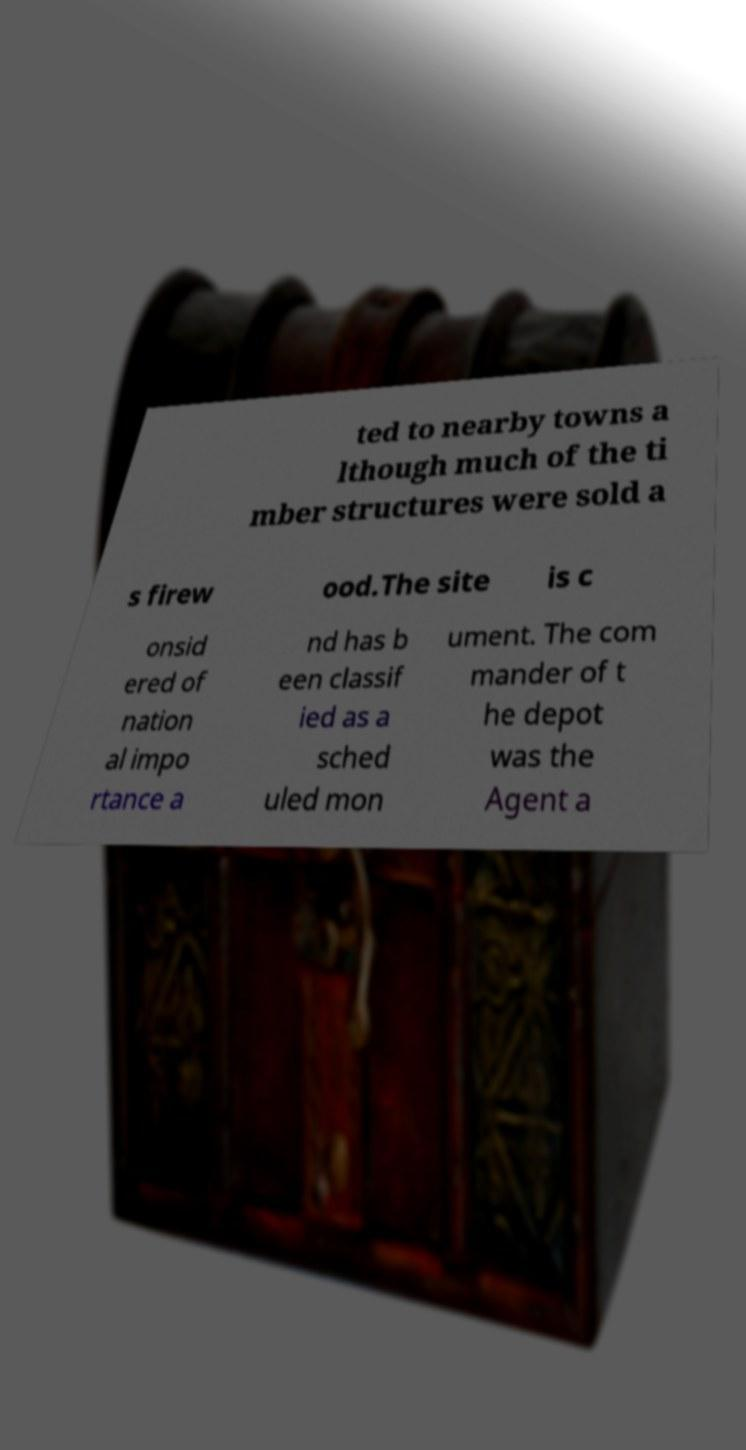Can you read and provide the text displayed in the image?This photo seems to have some interesting text. Can you extract and type it out for me? ted to nearby towns a lthough much of the ti mber structures were sold a s firew ood.The site is c onsid ered of nation al impo rtance a nd has b een classif ied as a sched uled mon ument. The com mander of t he depot was the Agent a 